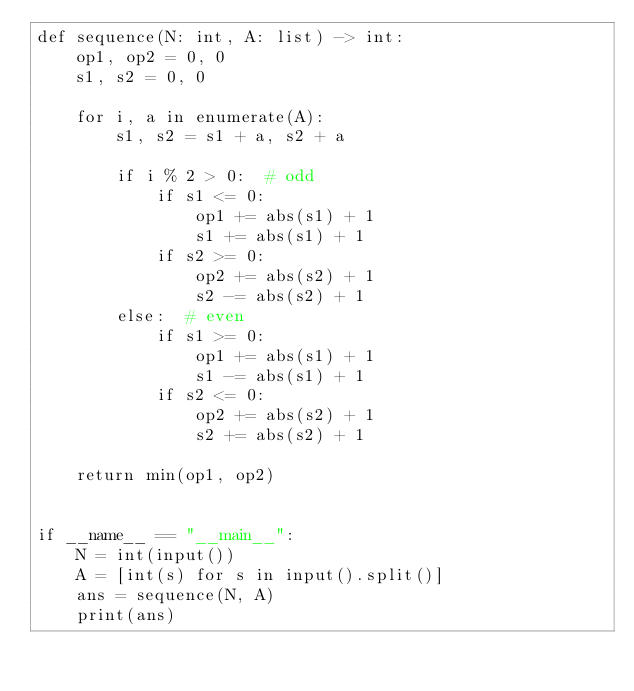Convert code to text. <code><loc_0><loc_0><loc_500><loc_500><_Python_>def sequence(N: int, A: list) -> int:
    op1, op2 = 0, 0
    s1, s2 = 0, 0

    for i, a in enumerate(A):
        s1, s2 = s1 + a, s2 + a

        if i % 2 > 0:  # odd
            if s1 <= 0:
                op1 += abs(s1) + 1
                s1 += abs(s1) + 1
            if s2 >= 0:
                op2 += abs(s2) + 1
                s2 -= abs(s2) + 1
        else:  # even
            if s1 >= 0:
                op1 += abs(s1) + 1
                s1 -= abs(s1) + 1
            if s2 <= 0:
                op2 += abs(s2) + 1
                s2 += abs(s2) + 1

    return min(op1, op2)


if __name__ == "__main__":
    N = int(input())
    A = [int(s) for s in input().split()]
    ans = sequence(N, A)
    print(ans)
</code> 